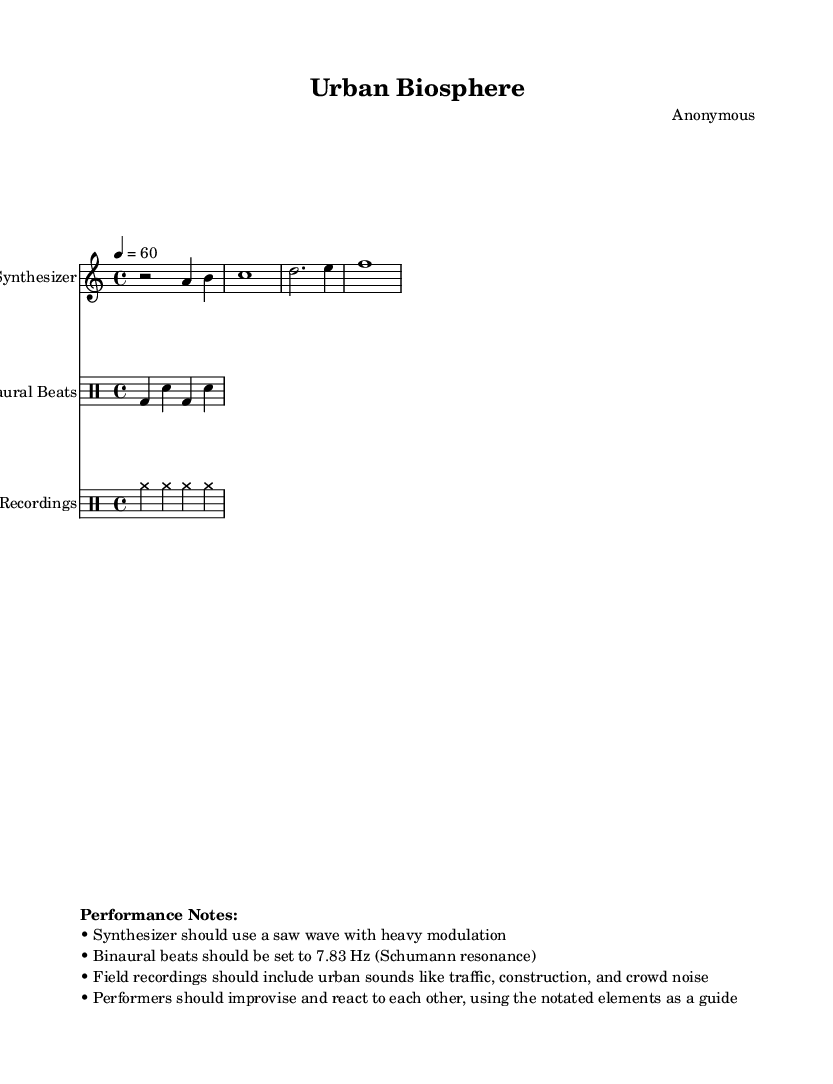What is the tempo of this composition? The tempo is indicated as 60 beats per minute in quarter note beats at the beginning of the score.
Answer: 60 What is the time signature of this piece? The time signature is indicated at the start of the score as 4/4, which means there are four beats in a measure and a quarter note gets one beat.
Answer: 4/4 What type of instrument is primarily used for the melody? The score identifies the primary instrument for the melody as the synthesizer, noted in the staff with that designation.
Answer: Synthesizer What frequency is suggested for the binaural beats? The performance notes explicitly state that the binaural beats should be set to 7.83 Hz, which is the frequency of the Schumann resonance.
Answer: 7.83 Hz How are performers instructed to interact during the performance? The performance notes advise that performers should improvise and react to each other while using the notated elements as a guideline, suggesting a collaborative approach.
Answer: Improvise What types of sounds should the field recordings include? The performance notes specify that field recordings should incorporate urban sounds, explicitly mentioning traffic, construction, and crowd noise for a lively soundscape.
Answer: Urban sounds What type of wave should the synthesizer use? The performance notes direct that the synthesizer should utilize a saw wave with heavy modulation, which shapes its timbre in the performance context.
Answer: Saw wave 